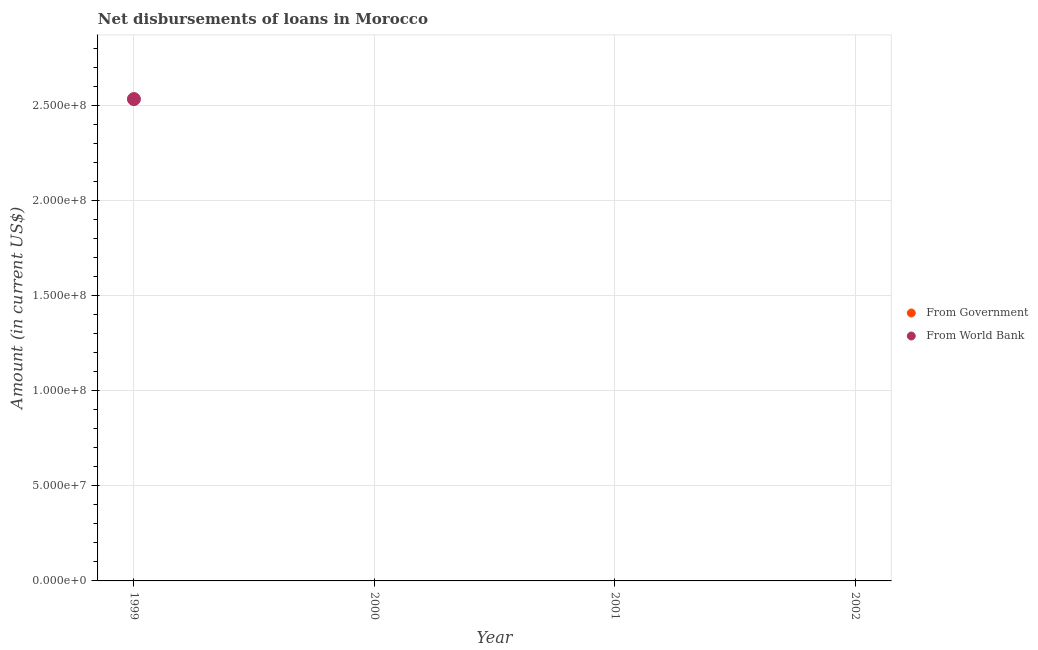Is the number of dotlines equal to the number of legend labels?
Your answer should be very brief. No. What is the net disbursements of loan from government in 2002?
Offer a terse response. 0. Across all years, what is the maximum net disbursements of loan from world bank?
Keep it short and to the point. 2.53e+08. Across all years, what is the minimum net disbursements of loan from government?
Make the answer very short. 0. What is the total net disbursements of loan from world bank in the graph?
Offer a very short reply. 2.53e+08. What is the difference between the net disbursements of loan from world bank in 1999 and the net disbursements of loan from government in 2002?
Offer a terse response. 2.53e+08. In how many years, is the net disbursements of loan from world bank greater than 50000000 US$?
Your answer should be very brief. 1. What is the difference between the highest and the lowest net disbursements of loan from world bank?
Your response must be concise. 2.53e+08. Does the net disbursements of loan from world bank monotonically increase over the years?
Provide a short and direct response. No. Is the net disbursements of loan from government strictly greater than the net disbursements of loan from world bank over the years?
Your answer should be very brief. No. How many years are there in the graph?
Your answer should be very brief. 4. Are the values on the major ticks of Y-axis written in scientific E-notation?
Offer a terse response. Yes. Does the graph contain any zero values?
Ensure brevity in your answer.  Yes. Does the graph contain grids?
Your answer should be compact. Yes. How many legend labels are there?
Your answer should be compact. 2. What is the title of the graph?
Your answer should be compact. Net disbursements of loans in Morocco. Does "Short-term debt" appear as one of the legend labels in the graph?
Keep it short and to the point. No. What is the label or title of the X-axis?
Provide a short and direct response. Year. What is the Amount (in current US$) of From Government in 1999?
Give a very brief answer. 0. What is the Amount (in current US$) in From World Bank in 1999?
Your response must be concise. 2.53e+08. What is the Amount (in current US$) in From Government in 2000?
Offer a terse response. 0. What is the Amount (in current US$) of From Government in 2001?
Offer a very short reply. 0. What is the Amount (in current US$) of From World Bank in 2002?
Your response must be concise. 0. Across all years, what is the maximum Amount (in current US$) of From World Bank?
Offer a terse response. 2.53e+08. What is the total Amount (in current US$) of From Government in the graph?
Keep it short and to the point. 0. What is the total Amount (in current US$) in From World Bank in the graph?
Your answer should be compact. 2.53e+08. What is the average Amount (in current US$) in From World Bank per year?
Provide a succinct answer. 6.34e+07. What is the difference between the highest and the lowest Amount (in current US$) in From World Bank?
Provide a short and direct response. 2.53e+08. 